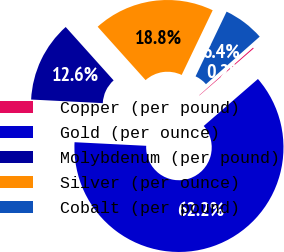Convert chart. <chart><loc_0><loc_0><loc_500><loc_500><pie_chart><fcel>Copper (per pound)<fcel>Gold (per ounce)<fcel>Molybdenum (per pound)<fcel>Silver (per ounce)<fcel>Cobalt (per pound)<nl><fcel>0.16%<fcel>62.17%<fcel>12.56%<fcel>18.76%<fcel>6.36%<nl></chart> 